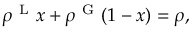Convert formula to latex. <formula><loc_0><loc_0><loc_500><loc_500>\rho ^ { L } x + \rho ^ { G } ( 1 - x ) = \rho ,</formula> 